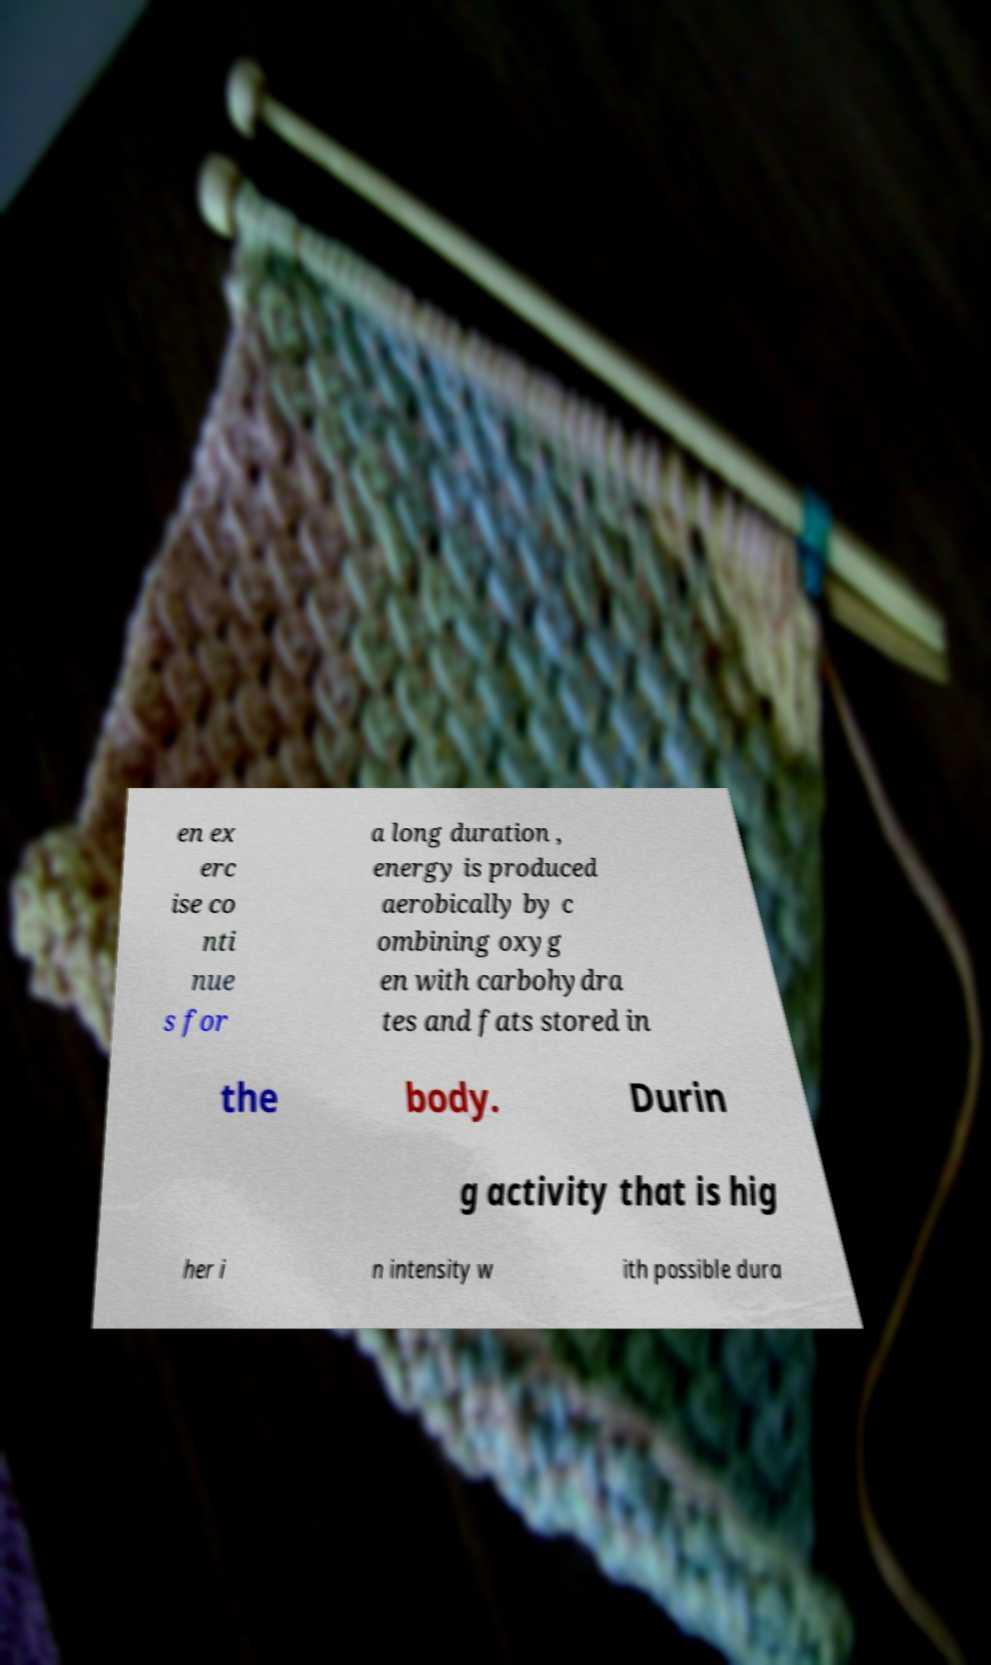Could you assist in decoding the text presented in this image and type it out clearly? en ex erc ise co nti nue s for a long duration , energy is produced aerobically by c ombining oxyg en with carbohydra tes and fats stored in the body. Durin g activity that is hig her i n intensity w ith possible dura 